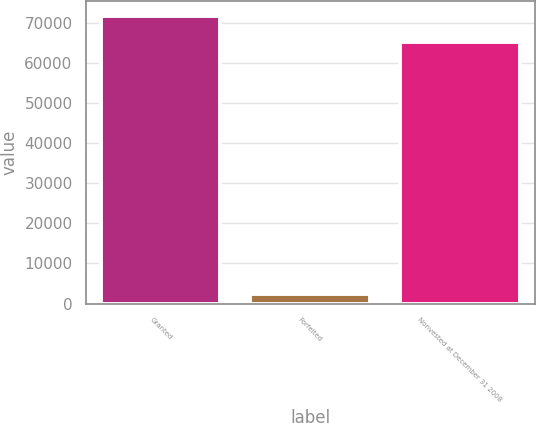Convert chart to OTSL. <chart><loc_0><loc_0><loc_500><loc_500><bar_chart><fcel>Granted<fcel>Forfeited<fcel>Nonvested at December 31 2008<nl><fcel>71896<fcel>2370<fcel>65360<nl></chart> 